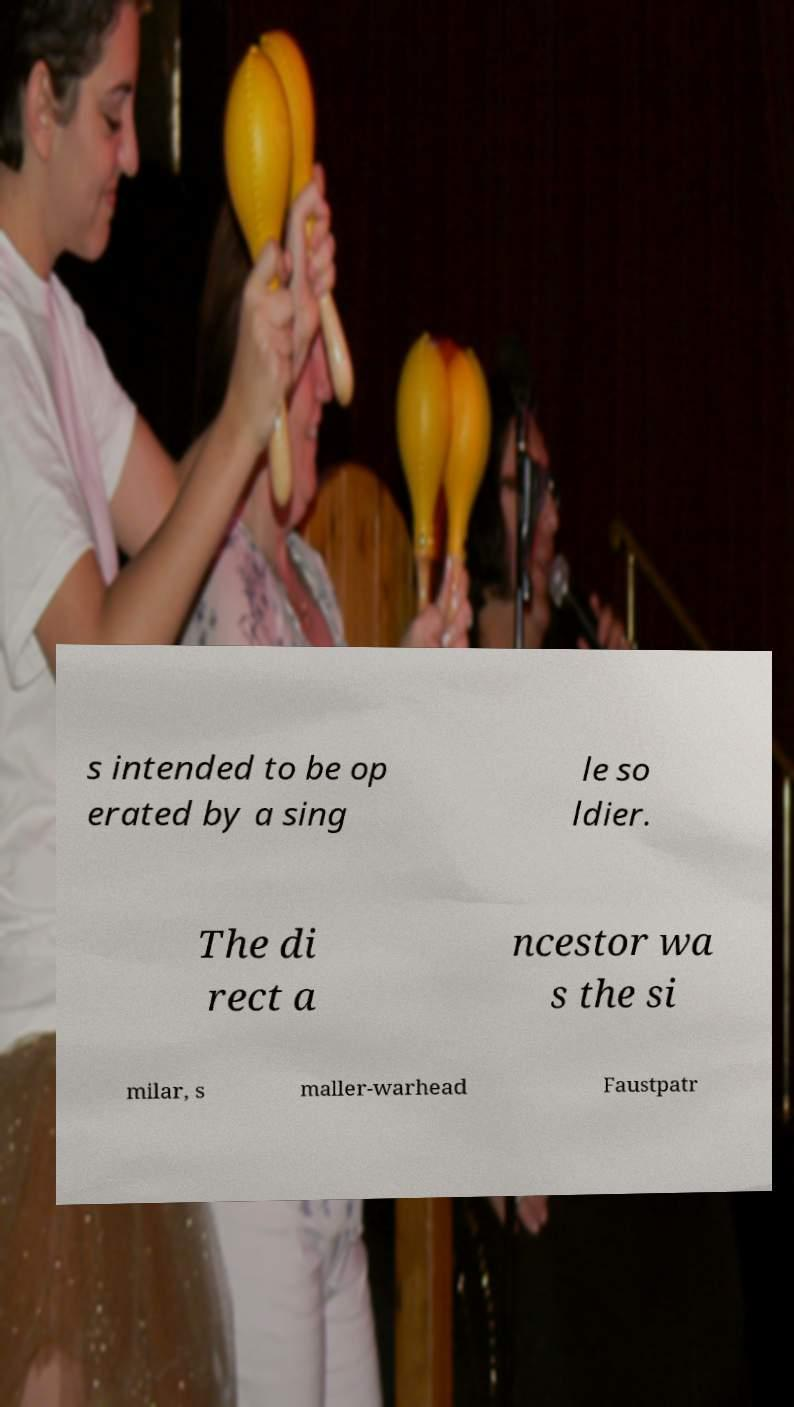Please identify and transcribe the text found in this image. s intended to be op erated by a sing le so ldier. The di rect a ncestor wa s the si milar, s maller-warhead Faustpatr 